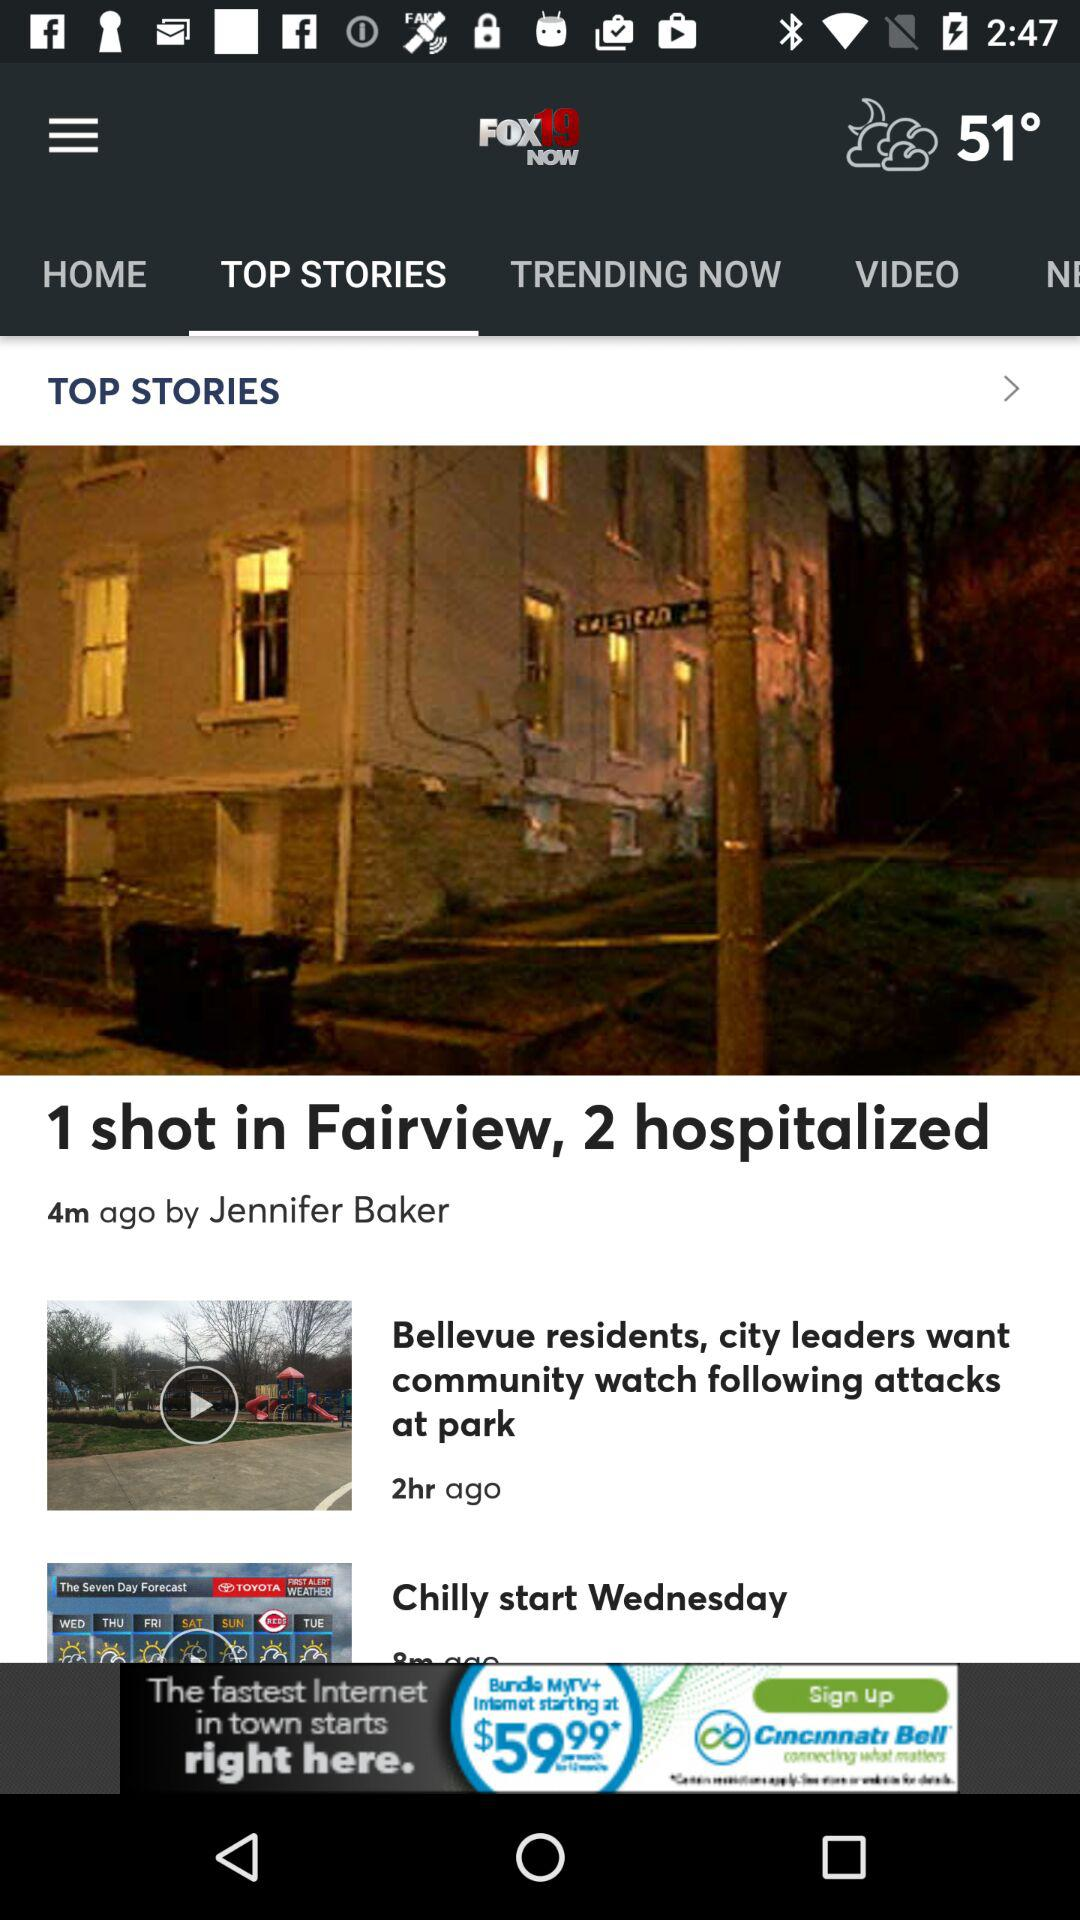How many people are hospitalized? There are 2 people hospitalized. 